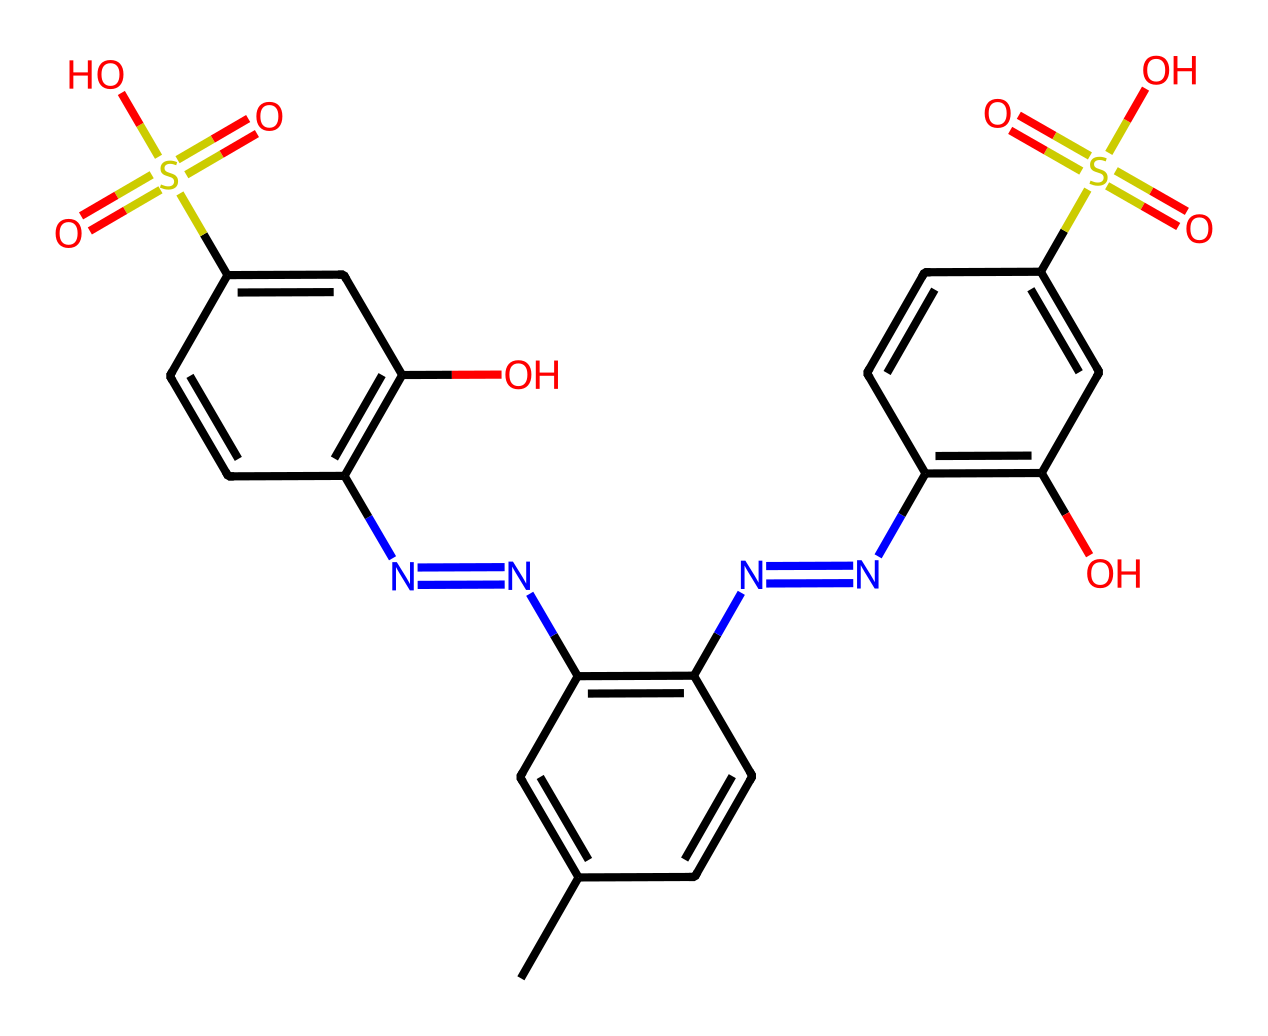What is the total number of aromatic rings present in this dye? A careful look at the structure shows that there are multiple benzene-like components in the molecule (aromatic rings are typically six-membered carbon rings with alternating double bonds). By identifying the distinct cycles, we see there are four aromatic rings.
Answer: four How many nitrogen atoms are present in this chemical structure? The SMILES representation includes two different types of nitrogen atoms embedded in the structure. By counting all the nitrogen atoms in the SMILES string, we find there are four nitrogen atoms.
Answer: four Does this dye contain any sulfonic acid groups? The structure contains a -SO3H group, commonly depicted as S(=O)(=O)O, indicating the presence of a sulfonic acid group. This group is important for the solubility and functionality of the dye.
Answer: yes What functional groups are present in this dye? To determine the functional groups, we can analyze the SMILES for recognizable patterns. We see amine groups (due to the nitrogen atoms), sulfonic acid groups, and hydroxyl groups (indicated by -OH). Thus, this dye contains amines, sulfonic acids, and alcohols.
Answer: amines, sulfonic acids, and alcohols How many hydroxyl (–OH) groups are present in the structure? Upon examining the structure, we can count the hydroxyl groups, which are indicated by the presence of -OH units. In the given SMILES, there are three -OH groups present.
Answer: three What type of chemical is this compound classified as? By analyzing the functional groups and the overall structure, this compound is specifically designed to be a dye due to its chromophoric system and electron-donor/acceptor characteristics. Hence, it is classified as a conductive dye.
Answer: conductive dye 